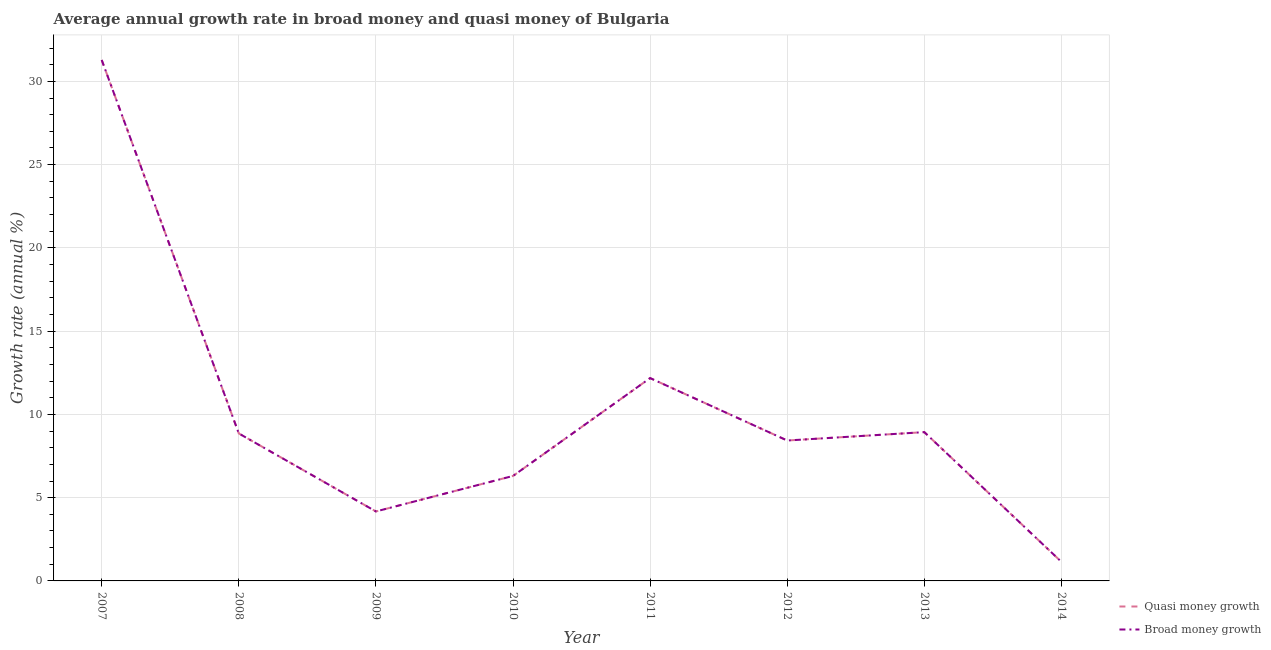How many different coloured lines are there?
Provide a short and direct response. 2. Does the line corresponding to annual growth rate in broad money intersect with the line corresponding to annual growth rate in quasi money?
Offer a terse response. Yes. Is the number of lines equal to the number of legend labels?
Ensure brevity in your answer.  Yes. What is the annual growth rate in quasi money in 2012?
Give a very brief answer. 8.43. Across all years, what is the maximum annual growth rate in broad money?
Make the answer very short. 31.29. Across all years, what is the minimum annual growth rate in quasi money?
Provide a short and direct response. 1.14. In which year was the annual growth rate in broad money maximum?
Ensure brevity in your answer.  2007. In which year was the annual growth rate in broad money minimum?
Offer a terse response. 2014. What is the total annual growth rate in broad money in the graph?
Your answer should be very brief. 81.31. What is the difference between the annual growth rate in quasi money in 2007 and that in 2013?
Keep it short and to the point. 22.35. What is the difference between the annual growth rate in broad money in 2012 and the annual growth rate in quasi money in 2010?
Your answer should be compact. 2.13. What is the average annual growth rate in quasi money per year?
Provide a succinct answer. 10.16. In the year 2007, what is the difference between the annual growth rate in quasi money and annual growth rate in broad money?
Your answer should be very brief. 0. What is the ratio of the annual growth rate in broad money in 2007 to that in 2008?
Provide a short and direct response. 3.53. What is the difference between the highest and the second highest annual growth rate in broad money?
Provide a succinct answer. 19.1. What is the difference between the highest and the lowest annual growth rate in broad money?
Provide a short and direct response. 30.14. Is the sum of the annual growth rate in broad money in 2007 and 2012 greater than the maximum annual growth rate in quasi money across all years?
Keep it short and to the point. Yes. Does the annual growth rate in quasi money monotonically increase over the years?
Your answer should be very brief. No. How many years are there in the graph?
Ensure brevity in your answer.  8. What is the difference between two consecutive major ticks on the Y-axis?
Your answer should be compact. 5. Where does the legend appear in the graph?
Keep it short and to the point. Bottom right. How many legend labels are there?
Provide a short and direct response. 2. How are the legend labels stacked?
Provide a short and direct response. Vertical. What is the title of the graph?
Provide a short and direct response. Average annual growth rate in broad money and quasi money of Bulgaria. What is the label or title of the X-axis?
Make the answer very short. Year. What is the label or title of the Y-axis?
Your response must be concise. Growth rate (annual %). What is the Growth rate (annual %) in Quasi money growth in 2007?
Your answer should be very brief. 31.29. What is the Growth rate (annual %) in Broad money growth in 2007?
Give a very brief answer. 31.29. What is the Growth rate (annual %) of Quasi money growth in 2008?
Your answer should be very brief. 8.86. What is the Growth rate (annual %) of Broad money growth in 2008?
Provide a succinct answer. 8.86. What is the Growth rate (annual %) of Quasi money growth in 2009?
Offer a terse response. 4.17. What is the Growth rate (annual %) in Broad money growth in 2009?
Provide a succinct answer. 4.17. What is the Growth rate (annual %) of Quasi money growth in 2010?
Ensure brevity in your answer.  6.3. What is the Growth rate (annual %) in Broad money growth in 2010?
Your response must be concise. 6.3. What is the Growth rate (annual %) in Quasi money growth in 2011?
Your answer should be very brief. 12.18. What is the Growth rate (annual %) in Broad money growth in 2011?
Provide a short and direct response. 12.18. What is the Growth rate (annual %) of Quasi money growth in 2012?
Keep it short and to the point. 8.43. What is the Growth rate (annual %) in Broad money growth in 2012?
Offer a terse response. 8.43. What is the Growth rate (annual %) of Quasi money growth in 2013?
Your answer should be very brief. 8.94. What is the Growth rate (annual %) of Broad money growth in 2013?
Give a very brief answer. 8.94. What is the Growth rate (annual %) of Quasi money growth in 2014?
Keep it short and to the point. 1.14. What is the Growth rate (annual %) of Broad money growth in 2014?
Offer a very short reply. 1.14. Across all years, what is the maximum Growth rate (annual %) of Quasi money growth?
Provide a succinct answer. 31.29. Across all years, what is the maximum Growth rate (annual %) in Broad money growth?
Provide a succinct answer. 31.29. Across all years, what is the minimum Growth rate (annual %) of Quasi money growth?
Give a very brief answer. 1.14. Across all years, what is the minimum Growth rate (annual %) in Broad money growth?
Give a very brief answer. 1.14. What is the total Growth rate (annual %) in Quasi money growth in the graph?
Keep it short and to the point. 81.31. What is the total Growth rate (annual %) of Broad money growth in the graph?
Offer a very short reply. 81.31. What is the difference between the Growth rate (annual %) of Quasi money growth in 2007 and that in 2008?
Offer a terse response. 22.43. What is the difference between the Growth rate (annual %) of Broad money growth in 2007 and that in 2008?
Offer a terse response. 22.43. What is the difference between the Growth rate (annual %) of Quasi money growth in 2007 and that in 2009?
Offer a very short reply. 27.11. What is the difference between the Growth rate (annual %) in Broad money growth in 2007 and that in 2009?
Your answer should be very brief. 27.11. What is the difference between the Growth rate (annual %) in Quasi money growth in 2007 and that in 2010?
Offer a very short reply. 24.98. What is the difference between the Growth rate (annual %) of Broad money growth in 2007 and that in 2010?
Your answer should be very brief. 24.98. What is the difference between the Growth rate (annual %) in Quasi money growth in 2007 and that in 2011?
Keep it short and to the point. 19.1. What is the difference between the Growth rate (annual %) in Broad money growth in 2007 and that in 2011?
Offer a terse response. 19.1. What is the difference between the Growth rate (annual %) of Quasi money growth in 2007 and that in 2012?
Your response must be concise. 22.85. What is the difference between the Growth rate (annual %) of Broad money growth in 2007 and that in 2012?
Your answer should be compact. 22.85. What is the difference between the Growth rate (annual %) of Quasi money growth in 2007 and that in 2013?
Your answer should be very brief. 22.35. What is the difference between the Growth rate (annual %) of Broad money growth in 2007 and that in 2013?
Make the answer very short. 22.35. What is the difference between the Growth rate (annual %) of Quasi money growth in 2007 and that in 2014?
Your answer should be compact. 30.14. What is the difference between the Growth rate (annual %) in Broad money growth in 2007 and that in 2014?
Offer a very short reply. 30.14. What is the difference between the Growth rate (annual %) in Quasi money growth in 2008 and that in 2009?
Offer a terse response. 4.68. What is the difference between the Growth rate (annual %) of Broad money growth in 2008 and that in 2009?
Offer a terse response. 4.68. What is the difference between the Growth rate (annual %) in Quasi money growth in 2008 and that in 2010?
Offer a very short reply. 2.55. What is the difference between the Growth rate (annual %) of Broad money growth in 2008 and that in 2010?
Make the answer very short. 2.55. What is the difference between the Growth rate (annual %) in Quasi money growth in 2008 and that in 2011?
Your answer should be very brief. -3.32. What is the difference between the Growth rate (annual %) in Broad money growth in 2008 and that in 2011?
Your response must be concise. -3.32. What is the difference between the Growth rate (annual %) in Quasi money growth in 2008 and that in 2012?
Ensure brevity in your answer.  0.42. What is the difference between the Growth rate (annual %) of Broad money growth in 2008 and that in 2012?
Offer a very short reply. 0.42. What is the difference between the Growth rate (annual %) of Quasi money growth in 2008 and that in 2013?
Keep it short and to the point. -0.08. What is the difference between the Growth rate (annual %) of Broad money growth in 2008 and that in 2013?
Offer a terse response. -0.08. What is the difference between the Growth rate (annual %) in Quasi money growth in 2008 and that in 2014?
Your response must be concise. 7.71. What is the difference between the Growth rate (annual %) in Broad money growth in 2008 and that in 2014?
Provide a succinct answer. 7.71. What is the difference between the Growth rate (annual %) in Quasi money growth in 2009 and that in 2010?
Provide a succinct answer. -2.13. What is the difference between the Growth rate (annual %) of Broad money growth in 2009 and that in 2010?
Make the answer very short. -2.13. What is the difference between the Growth rate (annual %) of Quasi money growth in 2009 and that in 2011?
Offer a terse response. -8.01. What is the difference between the Growth rate (annual %) in Broad money growth in 2009 and that in 2011?
Ensure brevity in your answer.  -8.01. What is the difference between the Growth rate (annual %) of Quasi money growth in 2009 and that in 2012?
Give a very brief answer. -4.26. What is the difference between the Growth rate (annual %) in Broad money growth in 2009 and that in 2012?
Your response must be concise. -4.26. What is the difference between the Growth rate (annual %) in Quasi money growth in 2009 and that in 2013?
Ensure brevity in your answer.  -4.76. What is the difference between the Growth rate (annual %) in Broad money growth in 2009 and that in 2013?
Your answer should be compact. -4.76. What is the difference between the Growth rate (annual %) of Quasi money growth in 2009 and that in 2014?
Your response must be concise. 3.03. What is the difference between the Growth rate (annual %) of Broad money growth in 2009 and that in 2014?
Keep it short and to the point. 3.03. What is the difference between the Growth rate (annual %) of Quasi money growth in 2010 and that in 2011?
Your response must be concise. -5.88. What is the difference between the Growth rate (annual %) in Broad money growth in 2010 and that in 2011?
Offer a terse response. -5.88. What is the difference between the Growth rate (annual %) in Quasi money growth in 2010 and that in 2012?
Ensure brevity in your answer.  -2.13. What is the difference between the Growth rate (annual %) of Broad money growth in 2010 and that in 2012?
Your answer should be compact. -2.13. What is the difference between the Growth rate (annual %) in Quasi money growth in 2010 and that in 2013?
Your answer should be compact. -2.63. What is the difference between the Growth rate (annual %) in Broad money growth in 2010 and that in 2013?
Provide a succinct answer. -2.63. What is the difference between the Growth rate (annual %) of Quasi money growth in 2010 and that in 2014?
Make the answer very short. 5.16. What is the difference between the Growth rate (annual %) of Broad money growth in 2010 and that in 2014?
Your response must be concise. 5.16. What is the difference between the Growth rate (annual %) in Quasi money growth in 2011 and that in 2012?
Offer a very short reply. 3.75. What is the difference between the Growth rate (annual %) of Broad money growth in 2011 and that in 2012?
Ensure brevity in your answer.  3.75. What is the difference between the Growth rate (annual %) of Quasi money growth in 2011 and that in 2013?
Provide a succinct answer. 3.25. What is the difference between the Growth rate (annual %) of Broad money growth in 2011 and that in 2013?
Your response must be concise. 3.25. What is the difference between the Growth rate (annual %) in Quasi money growth in 2011 and that in 2014?
Offer a terse response. 11.04. What is the difference between the Growth rate (annual %) of Broad money growth in 2011 and that in 2014?
Offer a very short reply. 11.04. What is the difference between the Growth rate (annual %) of Quasi money growth in 2012 and that in 2013?
Keep it short and to the point. -0.5. What is the difference between the Growth rate (annual %) in Broad money growth in 2012 and that in 2013?
Your answer should be very brief. -0.5. What is the difference between the Growth rate (annual %) of Quasi money growth in 2012 and that in 2014?
Ensure brevity in your answer.  7.29. What is the difference between the Growth rate (annual %) of Broad money growth in 2012 and that in 2014?
Keep it short and to the point. 7.29. What is the difference between the Growth rate (annual %) in Quasi money growth in 2013 and that in 2014?
Keep it short and to the point. 7.79. What is the difference between the Growth rate (annual %) of Broad money growth in 2013 and that in 2014?
Keep it short and to the point. 7.79. What is the difference between the Growth rate (annual %) in Quasi money growth in 2007 and the Growth rate (annual %) in Broad money growth in 2008?
Provide a succinct answer. 22.43. What is the difference between the Growth rate (annual %) of Quasi money growth in 2007 and the Growth rate (annual %) of Broad money growth in 2009?
Give a very brief answer. 27.11. What is the difference between the Growth rate (annual %) of Quasi money growth in 2007 and the Growth rate (annual %) of Broad money growth in 2010?
Make the answer very short. 24.98. What is the difference between the Growth rate (annual %) of Quasi money growth in 2007 and the Growth rate (annual %) of Broad money growth in 2011?
Your answer should be compact. 19.1. What is the difference between the Growth rate (annual %) of Quasi money growth in 2007 and the Growth rate (annual %) of Broad money growth in 2012?
Your answer should be compact. 22.85. What is the difference between the Growth rate (annual %) of Quasi money growth in 2007 and the Growth rate (annual %) of Broad money growth in 2013?
Offer a very short reply. 22.35. What is the difference between the Growth rate (annual %) in Quasi money growth in 2007 and the Growth rate (annual %) in Broad money growth in 2014?
Keep it short and to the point. 30.14. What is the difference between the Growth rate (annual %) in Quasi money growth in 2008 and the Growth rate (annual %) in Broad money growth in 2009?
Your answer should be very brief. 4.68. What is the difference between the Growth rate (annual %) of Quasi money growth in 2008 and the Growth rate (annual %) of Broad money growth in 2010?
Keep it short and to the point. 2.55. What is the difference between the Growth rate (annual %) in Quasi money growth in 2008 and the Growth rate (annual %) in Broad money growth in 2011?
Ensure brevity in your answer.  -3.32. What is the difference between the Growth rate (annual %) in Quasi money growth in 2008 and the Growth rate (annual %) in Broad money growth in 2012?
Give a very brief answer. 0.42. What is the difference between the Growth rate (annual %) of Quasi money growth in 2008 and the Growth rate (annual %) of Broad money growth in 2013?
Ensure brevity in your answer.  -0.08. What is the difference between the Growth rate (annual %) in Quasi money growth in 2008 and the Growth rate (annual %) in Broad money growth in 2014?
Your response must be concise. 7.71. What is the difference between the Growth rate (annual %) of Quasi money growth in 2009 and the Growth rate (annual %) of Broad money growth in 2010?
Provide a short and direct response. -2.13. What is the difference between the Growth rate (annual %) of Quasi money growth in 2009 and the Growth rate (annual %) of Broad money growth in 2011?
Provide a short and direct response. -8.01. What is the difference between the Growth rate (annual %) in Quasi money growth in 2009 and the Growth rate (annual %) in Broad money growth in 2012?
Make the answer very short. -4.26. What is the difference between the Growth rate (annual %) of Quasi money growth in 2009 and the Growth rate (annual %) of Broad money growth in 2013?
Provide a succinct answer. -4.76. What is the difference between the Growth rate (annual %) of Quasi money growth in 2009 and the Growth rate (annual %) of Broad money growth in 2014?
Provide a short and direct response. 3.03. What is the difference between the Growth rate (annual %) in Quasi money growth in 2010 and the Growth rate (annual %) in Broad money growth in 2011?
Offer a very short reply. -5.88. What is the difference between the Growth rate (annual %) in Quasi money growth in 2010 and the Growth rate (annual %) in Broad money growth in 2012?
Ensure brevity in your answer.  -2.13. What is the difference between the Growth rate (annual %) of Quasi money growth in 2010 and the Growth rate (annual %) of Broad money growth in 2013?
Offer a terse response. -2.63. What is the difference between the Growth rate (annual %) of Quasi money growth in 2010 and the Growth rate (annual %) of Broad money growth in 2014?
Make the answer very short. 5.16. What is the difference between the Growth rate (annual %) of Quasi money growth in 2011 and the Growth rate (annual %) of Broad money growth in 2012?
Your answer should be very brief. 3.75. What is the difference between the Growth rate (annual %) in Quasi money growth in 2011 and the Growth rate (annual %) in Broad money growth in 2013?
Provide a succinct answer. 3.25. What is the difference between the Growth rate (annual %) in Quasi money growth in 2011 and the Growth rate (annual %) in Broad money growth in 2014?
Offer a very short reply. 11.04. What is the difference between the Growth rate (annual %) of Quasi money growth in 2012 and the Growth rate (annual %) of Broad money growth in 2013?
Make the answer very short. -0.5. What is the difference between the Growth rate (annual %) in Quasi money growth in 2012 and the Growth rate (annual %) in Broad money growth in 2014?
Give a very brief answer. 7.29. What is the difference between the Growth rate (annual %) in Quasi money growth in 2013 and the Growth rate (annual %) in Broad money growth in 2014?
Provide a short and direct response. 7.79. What is the average Growth rate (annual %) in Quasi money growth per year?
Keep it short and to the point. 10.16. What is the average Growth rate (annual %) in Broad money growth per year?
Ensure brevity in your answer.  10.16. In the year 2009, what is the difference between the Growth rate (annual %) of Quasi money growth and Growth rate (annual %) of Broad money growth?
Provide a succinct answer. 0. What is the ratio of the Growth rate (annual %) of Quasi money growth in 2007 to that in 2008?
Ensure brevity in your answer.  3.53. What is the ratio of the Growth rate (annual %) of Broad money growth in 2007 to that in 2008?
Offer a terse response. 3.53. What is the ratio of the Growth rate (annual %) in Quasi money growth in 2007 to that in 2009?
Offer a terse response. 7.5. What is the ratio of the Growth rate (annual %) of Broad money growth in 2007 to that in 2009?
Ensure brevity in your answer.  7.5. What is the ratio of the Growth rate (annual %) in Quasi money growth in 2007 to that in 2010?
Ensure brevity in your answer.  4.96. What is the ratio of the Growth rate (annual %) of Broad money growth in 2007 to that in 2010?
Keep it short and to the point. 4.96. What is the ratio of the Growth rate (annual %) of Quasi money growth in 2007 to that in 2011?
Ensure brevity in your answer.  2.57. What is the ratio of the Growth rate (annual %) of Broad money growth in 2007 to that in 2011?
Your response must be concise. 2.57. What is the ratio of the Growth rate (annual %) in Quasi money growth in 2007 to that in 2012?
Provide a short and direct response. 3.71. What is the ratio of the Growth rate (annual %) in Broad money growth in 2007 to that in 2012?
Make the answer very short. 3.71. What is the ratio of the Growth rate (annual %) in Quasi money growth in 2007 to that in 2013?
Give a very brief answer. 3.5. What is the ratio of the Growth rate (annual %) of Broad money growth in 2007 to that in 2013?
Provide a succinct answer. 3.5. What is the ratio of the Growth rate (annual %) in Quasi money growth in 2007 to that in 2014?
Your answer should be compact. 27.35. What is the ratio of the Growth rate (annual %) of Broad money growth in 2007 to that in 2014?
Ensure brevity in your answer.  27.35. What is the ratio of the Growth rate (annual %) of Quasi money growth in 2008 to that in 2009?
Offer a terse response. 2.12. What is the ratio of the Growth rate (annual %) in Broad money growth in 2008 to that in 2009?
Provide a short and direct response. 2.12. What is the ratio of the Growth rate (annual %) in Quasi money growth in 2008 to that in 2010?
Keep it short and to the point. 1.4. What is the ratio of the Growth rate (annual %) of Broad money growth in 2008 to that in 2010?
Offer a very short reply. 1.4. What is the ratio of the Growth rate (annual %) in Quasi money growth in 2008 to that in 2011?
Your answer should be compact. 0.73. What is the ratio of the Growth rate (annual %) in Broad money growth in 2008 to that in 2011?
Offer a very short reply. 0.73. What is the ratio of the Growth rate (annual %) of Quasi money growth in 2008 to that in 2012?
Offer a terse response. 1.05. What is the ratio of the Growth rate (annual %) of Broad money growth in 2008 to that in 2012?
Your response must be concise. 1.05. What is the ratio of the Growth rate (annual %) of Quasi money growth in 2008 to that in 2014?
Give a very brief answer. 7.74. What is the ratio of the Growth rate (annual %) of Broad money growth in 2008 to that in 2014?
Your answer should be very brief. 7.74. What is the ratio of the Growth rate (annual %) in Quasi money growth in 2009 to that in 2010?
Ensure brevity in your answer.  0.66. What is the ratio of the Growth rate (annual %) of Broad money growth in 2009 to that in 2010?
Provide a short and direct response. 0.66. What is the ratio of the Growth rate (annual %) of Quasi money growth in 2009 to that in 2011?
Make the answer very short. 0.34. What is the ratio of the Growth rate (annual %) in Broad money growth in 2009 to that in 2011?
Your answer should be compact. 0.34. What is the ratio of the Growth rate (annual %) in Quasi money growth in 2009 to that in 2012?
Your answer should be compact. 0.49. What is the ratio of the Growth rate (annual %) of Broad money growth in 2009 to that in 2012?
Ensure brevity in your answer.  0.49. What is the ratio of the Growth rate (annual %) in Quasi money growth in 2009 to that in 2013?
Keep it short and to the point. 0.47. What is the ratio of the Growth rate (annual %) in Broad money growth in 2009 to that in 2013?
Ensure brevity in your answer.  0.47. What is the ratio of the Growth rate (annual %) of Quasi money growth in 2009 to that in 2014?
Offer a very short reply. 3.65. What is the ratio of the Growth rate (annual %) in Broad money growth in 2009 to that in 2014?
Ensure brevity in your answer.  3.65. What is the ratio of the Growth rate (annual %) in Quasi money growth in 2010 to that in 2011?
Ensure brevity in your answer.  0.52. What is the ratio of the Growth rate (annual %) of Broad money growth in 2010 to that in 2011?
Make the answer very short. 0.52. What is the ratio of the Growth rate (annual %) of Quasi money growth in 2010 to that in 2012?
Your answer should be compact. 0.75. What is the ratio of the Growth rate (annual %) in Broad money growth in 2010 to that in 2012?
Give a very brief answer. 0.75. What is the ratio of the Growth rate (annual %) of Quasi money growth in 2010 to that in 2013?
Make the answer very short. 0.71. What is the ratio of the Growth rate (annual %) in Broad money growth in 2010 to that in 2013?
Keep it short and to the point. 0.71. What is the ratio of the Growth rate (annual %) of Quasi money growth in 2010 to that in 2014?
Offer a very short reply. 5.51. What is the ratio of the Growth rate (annual %) of Broad money growth in 2010 to that in 2014?
Ensure brevity in your answer.  5.51. What is the ratio of the Growth rate (annual %) of Quasi money growth in 2011 to that in 2012?
Your answer should be very brief. 1.44. What is the ratio of the Growth rate (annual %) of Broad money growth in 2011 to that in 2012?
Make the answer very short. 1.44. What is the ratio of the Growth rate (annual %) in Quasi money growth in 2011 to that in 2013?
Provide a short and direct response. 1.36. What is the ratio of the Growth rate (annual %) in Broad money growth in 2011 to that in 2013?
Ensure brevity in your answer.  1.36. What is the ratio of the Growth rate (annual %) of Quasi money growth in 2011 to that in 2014?
Provide a short and direct response. 10.65. What is the ratio of the Growth rate (annual %) of Broad money growth in 2011 to that in 2014?
Your response must be concise. 10.65. What is the ratio of the Growth rate (annual %) of Quasi money growth in 2012 to that in 2013?
Your answer should be very brief. 0.94. What is the ratio of the Growth rate (annual %) of Broad money growth in 2012 to that in 2013?
Ensure brevity in your answer.  0.94. What is the ratio of the Growth rate (annual %) of Quasi money growth in 2012 to that in 2014?
Offer a very short reply. 7.37. What is the ratio of the Growth rate (annual %) of Broad money growth in 2012 to that in 2014?
Offer a very short reply. 7.37. What is the ratio of the Growth rate (annual %) of Quasi money growth in 2013 to that in 2014?
Your answer should be compact. 7.81. What is the ratio of the Growth rate (annual %) of Broad money growth in 2013 to that in 2014?
Your response must be concise. 7.81. What is the difference between the highest and the second highest Growth rate (annual %) in Quasi money growth?
Ensure brevity in your answer.  19.1. What is the difference between the highest and the second highest Growth rate (annual %) in Broad money growth?
Give a very brief answer. 19.1. What is the difference between the highest and the lowest Growth rate (annual %) of Quasi money growth?
Ensure brevity in your answer.  30.14. What is the difference between the highest and the lowest Growth rate (annual %) of Broad money growth?
Your response must be concise. 30.14. 